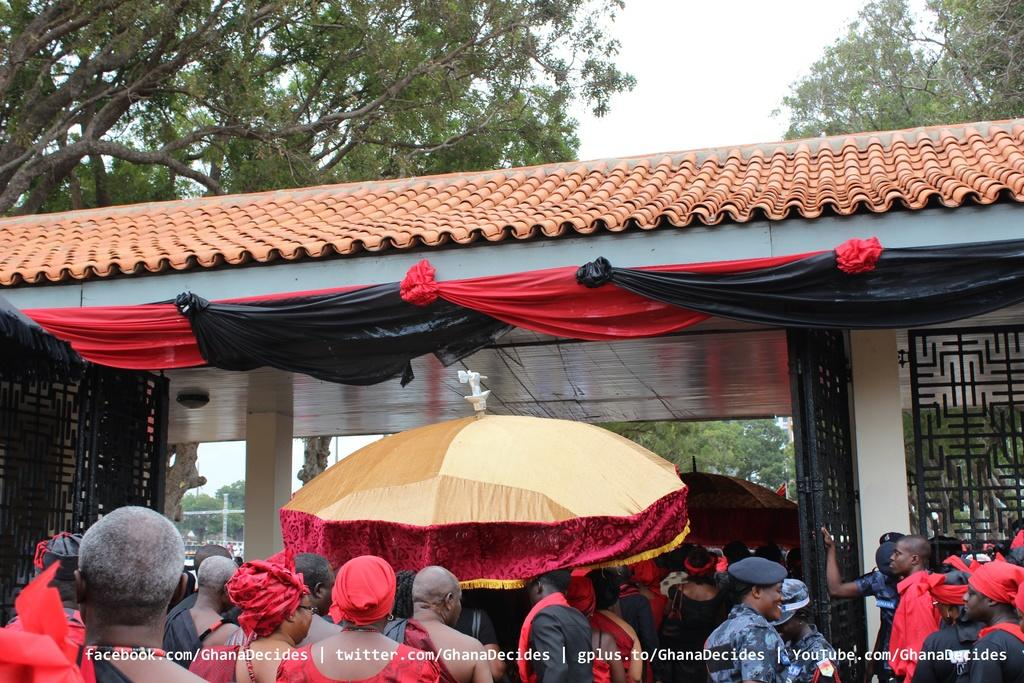What type of structure is visible in the image? There is a house in the image. What else can be seen in the image besides the house? There are tents, trees, and many people at the bottom of the image. What is visible in the background of the image? The sky is visible in the image. Is there any text present in the image? Yes, there is text in the image. What type of income can be seen in the image? There is no reference to income in the image; it features a house, tents, trees, people, the sky, and text. Can you tell me how many yaks are present in the image? There are no yaks present in the image. 